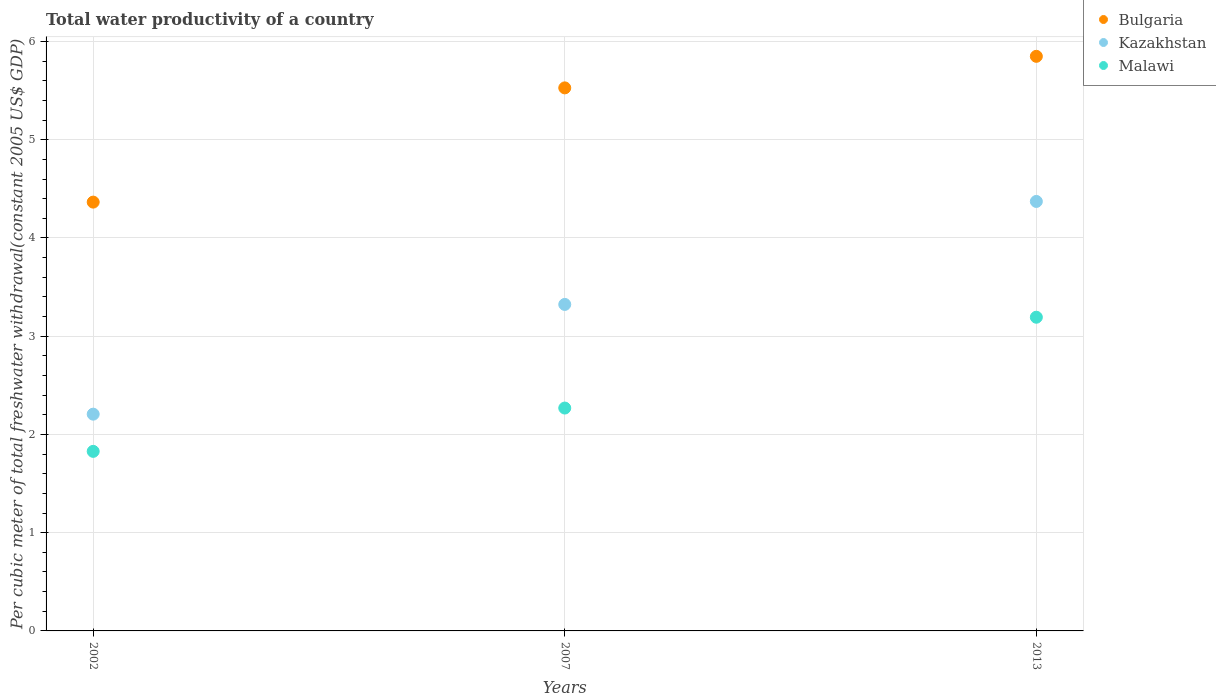What is the total water productivity in Bulgaria in 2013?
Keep it short and to the point. 5.85. Across all years, what is the maximum total water productivity in Malawi?
Ensure brevity in your answer.  3.19. Across all years, what is the minimum total water productivity in Kazakhstan?
Give a very brief answer. 2.21. In which year was the total water productivity in Malawi maximum?
Make the answer very short. 2013. In which year was the total water productivity in Bulgaria minimum?
Your answer should be compact. 2002. What is the total total water productivity in Kazakhstan in the graph?
Your answer should be very brief. 9.9. What is the difference between the total water productivity in Bulgaria in 2002 and that in 2007?
Offer a very short reply. -1.16. What is the difference between the total water productivity in Kazakhstan in 2013 and the total water productivity in Malawi in 2007?
Ensure brevity in your answer.  2.1. What is the average total water productivity in Bulgaria per year?
Your answer should be very brief. 5.25. In the year 2013, what is the difference between the total water productivity in Kazakhstan and total water productivity in Malawi?
Ensure brevity in your answer.  1.18. In how many years, is the total water productivity in Kazakhstan greater than 5.4 US$?
Offer a very short reply. 0. What is the ratio of the total water productivity in Kazakhstan in 2002 to that in 2007?
Make the answer very short. 0.66. What is the difference between the highest and the second highest total water productivity in Kazakhstan?
Your answer should be compact. 1.05. What is the difference between the highest and the lowest total water productivity in Bulgaria?
Provide a short and direct response. 1.48. Is the sum of the total water productivity in Kazakhstan in 2002 and 2013 greater than the maximum total water productivity in Bulgaria across all years?
Give a very brief answer. Yes. Does the total water productivity in Malawi monotonically increase over the years?
Provide a succinct answer. Yes. Is the total water productivity in Kazakhstan strictly greater than the total water productivity in Malawi over the years?
Offer a very short reply. Yes. Is the total water productivity in Kazakhstan strictly less than the total water productivity in Bulgaria over the years?
Give a very brief answer. Yes. How many years are there in the graph?
Provide a succinct answer. 3. Are the values on the major ticks of Y-axis written in scientific E-notation?
Provide a succinct answer. No. Does the graph contain grids?
Make the answer very short. Yes. How many legend labels are there?
Provide a succinct answer. 3. What is the title of the graph?
Your response must be concise. Total water productivity of a country. Does "Nigeria" appear as one of the legend labels in the graph?
Keep it short and to the point. No. What is the label or title of the X-axis?
Keep it short and to the point. Years. What is the label or title of the Y-axis?
Ensure brevity in your answer.  Per cubic meter of total freshwater withdrawal(constant 2005 US$ GDP). What is the Per cubic meter of total freshwater withdrawal(constant 2005 US$ GDP) in Bulgaria in 2002?
Ensure brevity in your answer.  4.37. What is the Per cubic meter of total freshwater withdrawal(constant 2005 US$ GDP) of Kazakhstan in 2002?
Offer a very short reply. 2.21. What is the Per cubic meter of total freshwater withdrawal(constant 2005 US$ GDP) in Malawi in 2002?
Provide a short and direct response. 1.83. What is the Per cubic meter of total freshwater withdrawal(constant 2005 US$ GDP) of Bulgaria in 2007?
Offer a terse response. 5.53. What is the Per cubic meter of total freshwater withdrawal(constant 2005 US$ GDP) of Kazakhstan in 2007?
Provide a short and direct response. 3.32. What is the Per cubic meter of total freshwater withdrawal(constant 2005 US$ GDP) of Malawi in 2007?
Make the answer very short. 2.27. What is the Per cubic meter of total freshwater withdrawal(constant 2005 US$ GDP) of Bulgaria in 2013?
Ensure brevity in your answer.  5.85. What is the Per cubic meter of total freshwater withdrawal(constant 2005 US$ GDP) of Kazakhstan in 2013?
Offer a terse response. 4.37. What is the Per cubic meter of total freshwater withdrawal(constant 2005 US$ GDP) in Malawi in 2013?
Provide a short and direct response. 3.19. Across all years, what is the maximum Per cubic meter of total freshwater withdrawal(constant 2005 US$ GDP) in Bulgaria?
Your answer should be compact. 5.85. Across all years, what is the maximum Per cubic meter of total freshwater withdrawal(constant 2005 US$ GDP) of Kazakhstan?
Your answer should be very brief. 4.37. Across all years, what is the maximum Per cubic meter of total freshwater withdrawal(constant 2005 US$ GDP) in Malawi?
Provide a succinct answer. 3.19. Across all years, what is the minimum Per cubic meter of total freshwater withdrawal(constant 2005 US$ GDP) in Bulgaria?
Ensure brevity in your answer.  4.37. Across all years, what is the minimum Per cubic meter of total freshwater withdrawal(constant 2005 US$ GDP) of Kazakhstan?
Your answer should be very brief. 2.21. Across all years, what is the minimum Per cubic meter of total freshwater withdrawal(constant 2005 US$ GDP) in Malawi?
Provide a succinct answer. 1.83. What is the total Per cubic meter of total freshwater withdrawal(constant 2005 US$ GDP) of Bulgaria in the graph?
Offer a terse response. 15.74. What is the total Per cubic meter of total freshwater withdrawal(constant 2005 US$ GDP) in Kazakhstan in the graph?
Make the answer very short. 9.9. What is the total Per cubic meter of total freshwater withdrawal(constant 2005 US$ GDP) in Malawi in the graph?
Your response must be concise. 7.29. What is the difference between the Per cubic meter of total freshwater withdrawal(constant 2005 US$ GDP) of Bulgaria in 2002 and that in 2007?
Make the answer very short. -1.16. What is the difference between the Per cubic meter of total freshwater withdrawal(constant 2005 US$ GDP) of Kazakhstan in 2002 and that in 2007?
Provide a succinct answer. -1.12. What is the difference between the Per cubic meter of total freshwater withdrawal(constant 2005 US$ GDP) in Malawi in 2002 and that in 2007?
Your answer should be very brief. -0.44. What is the difference between the Per cubic meter of total freshwater withdrawal(constant 2005 US$ GDP) of Bulgaria in 2002 and that in 2013?
Your answer should be very brief. -1.48. What is the difference between the Per cubic meter of total freshwater withdrawal(constant 2005 US$ GDP) of Kazakhstan in 2002 and that in 2013?
Offer a very short reply. -2.17. What is the difference between the Per cubic meter of total freshwater withdrawal(constant 2005 US$ GDP) of Malawi in 2002 and that in 2013?
Your answer should be very brief. -1.37. What is the difference between the Per cubic meter of total freshwater withdrawal(constant 2005 US$ GDP) in Bulgaria in 2007 and that in 2013?
Your answer should be compact. -0.32. What is the difference between the Per cubic meter of total freshwater withdrawal(constant 2005 US$ GDP) of Kazakhstan in 2007 and that in 2013?
Give a very brief answer. -1.05. What is the difference between the Per cubic meter of total freshwater withdrawal(constant 2005 US$ GDP) of Malawi in 2007 and that in 2013?
Your answer should be compact. -0.92. What is the difference between the Per cubic meter of total freshwater withdrawal(constant 2005 US$ GDP) in Bulgaria in 2002 and the Per cubic meter of total freshwater withdrawal(constant 2005 US$ GDP) in Kazakhstan in 2007?
Offer a terse response. 1.04. What is the difference between the Per cubic meter of total freshwater withdrawal(constant 2005 US$ GDP) of Bulgaria in 2002 and the Per cubic meter of total freshwater withdrawal(constant 2005 US$ GDP) of Malawi in 2007?
Offer a very short reply. 2.1. What is the difference between the Per cubic meter of total freshwater withdrawal(constant 2005 US$ GDP) in Kazakhstan in 2002 and the Per cubic meter of total freshwater withdrawal(constant 2005 US$ GDP) in Malawi in 2007?
Your answer should be very brief. -0.06. What is the difference between the Per cubic meter of total freshwater withdrawal(constant 2005 US$ GDP) in Bulgaria in 2002 and the Per cubic meter of total freshwater withdrawal(constant 2005 US$ GDP) in Kazakhstan in 2013?
Your answer should be compact. -0.01. What is the difference between the Per cubic meter of total freshwater withdrawal(constant 2005 US$ GDP) of Bulgaria in 2002 and the Per cubic meter of total freshwater withdrawal(constant 2005 US$ GDP) of Malawi in 2013?
Offer a very short reply. 1.17. What is the difference between the Per cubic meter of total freshwater withdrawal(constant 2005 US$ GDP) in Kazakhstan in 2002 and the Per cubic meter of total freshwater withdrawal(constant 2005 US$ GDP) in Malawi in 2013?
Your answer should be very brief. -0.99. What is the difference between the Per cubic meter of total freshwater withdrawal(constant 2005 US$ GDP) of Bulgaria in 2007 and the Per cubic meter of total freshwater withdrawal(constant 2005 US$ GDP) of Kazakhstan in 2013?
Keep it short and to the point. 1.16. What is the difference between the Per cubic meter of total freshwater withdrawal(constant 2005 US$ GDP) of Bulgaria in 2007 and the Per cubic meter of total freshwater withdrawal(constant 2005 US$ GDP) of Malawi in 2013?
Your response must be concise. 2.33. What is the difference between the Per cubic meter of total freshwater withdrawal(constant 2005 US$ GDP) of Kazakhstan in 2007 and the Per cubic meter of total freshwater withdrawal(constant 2005 US$ GDP) of Malawi in 2013?
Your response must be concise. 0.13. What is the average Per cubic meter of total freshwater withdrawal(constant 2005 US$ GDP) of Bulgaria per year?
Your response must be concise. 5.25. What is the average Per cubic meter of total freshwater withdrawal(constant 2005 US$ GDP) in Kazakhstan per year?
Your answer should be very brief. 3.3. What is the average Per cubic meter of total freshwater withdrawal(constant 2005 US$ GDP) of Malawi per year?
Provide a short and direct response. 2.43. In the year 2002, what is the difference between the Per cubic meter of total freshwater withdrawal(constant 2005 US$ GDP) in Bulgaria and Per cubic meter of total freshwater withdrawal(constant 2005 US$ GDP) in Kazakhstan?
Keep it short and to the point. 2.16. In the year 2002, what is the difference between the Per cubic meter of total freshwater withdrawal(constant 2005 US$ GDP) of Bulgaria and Per cubic meter of total freshwater withdrawal(constant 2005 US$ GDP) of Malawi?
Offer a terse response. 2.54. In the year 2002, what is the difference between the Per cubic meter of total freshwater withdrawal(constant 2005 US$ GDP) in Kazakhstan and Per cubic meter of total freshwater withdrawal(constant 2005 US$ GDP) in Malawi?
Your answer should be compact. 0.38. In the year 2007, what is the difference between the Per cubic meter of total freshwater withdrawal(constant 2005 US$ GDP) of Bulgaria and Per cubic meter of total freshwater withdrawal(constant 2005 US$ GDP) of Kazakhstan?
Offer a very short reply. 2.2. In the year 2007, what is the difference between the Per cubic meter of total freshwater withdrawal(constant 2005 US$ GDP) of Bulgaria and Per cubic meter of total freshwater withdrawal(constant 2005 US$ GDP) of Malawi?
Give a very brief answer. 3.26. In the year 2007, what is the difference between the Per cubic meter of total freshwater withdrawal(constant 2005 US$ GDP) of Kazakhstan and Per cubic meter of total freshwater withdrawal(constant 2005 US$ GDP) of Malawi?
Offer a terse response. 1.05. In the year 2013, what is the difference between the Per cubic meter of total freshwater withdrawal(constant 2005 US$ GDP) of Bulgaria and Per cubic meter of total freshwater withdrawal(constant 2005 US$ GDP) of Kazakhstan?
Your answer should be compact. 1.48. In the year 2013, what is the difference between the Per cubic meter of total freshwater withdrawal(constant 2005 US$ GDP) of Bulgaria and Per cubic meter of total freshwater withdrawal(constant 2005 US$ GDP) of Malawi?
Your response must be concise. 2.66. In the year 2013, what is the difference between the Per cubic meter of total freshwater withdrawal(constant 2005 US$ GDP) of Kazakhstan and Per cubic meter of total freshwater withdrawal(constant 2005 US$ GDP) of Malawi?
Make the answer very short. 1.18. What is the ratio of the Per cubic meter of total freshwater withdrawal(constant 2005 US$ GDP) of Bulgaria in 2002 to that in 2007?
Offer a terse response. 0.79. What is the ratio of the Per cubic meter of total freshwater withdrawal(constant 2005 US$ GDP) of Kazakhstan in 2002 to that in 2007?
Keep it short and to the point. 0.66. What is the ratio of the Per cubic meter of total freshwater withdrawal(constant 2005 US$ GDP) in Malawi in 2002 to that in 2007?
Offer a very short reply. 0.81. What is the ratio of the Per cubic meter of total freshwater withdrawal(constant 2005 US$ GDP) of Bulgaria in 2002 to that in 2013?
Make the answer very short. 0.75. What is the ratio of the Per cubic meter of total freshwater withdrawal(constant 2005 US$ GDP) in Kazakhstan in 2002 to that in 2013?
Your answer should be very brief. 0.5. What is the ratio of the Per cubic meter of total freshwater withdrawal(constant 2005 US$ GDP) of Malawi in 2002 to that in 2013?
Provide a succinct answer. 0.57. What is the ratio of the Per cubic meter of total freshwater withdrawal(constant 2005 US$ GDP) of Bulgaria in 2007 to that in 2013?
Ensure brevity in your answer.  0.95. What is the ratio of the Per cubic meter of total freshwater withdrawal(constant 2005 US$ GDP) of Kazakhstan in 2007 to that in 2013?
Make the answer very short. 0.76. What is the ratio of the Per cubic meter of total freshwater withdrawal(constant 2005 US$ GDP) of Malawi in 2007 to that in 2013?
Your answer should be very brief. 0.71. What is the difference between the highest and the second highest Per cubic meter of total freshwater withdrawal(constant 2005 US$ GDP) of Bulgaria?
Your response must be concise. 0.32. What is the difference between the highest and the second highest Per cubic meter of total freshwater withdrawal(constant 2005 US$ GDP) in Kazakhstan?
Offer a very short reply. 1.05. What is the difference between the highest and the second highest Per cubic meter of total freshwater withdrawal(constant 2005 US$ GDP) of Malawi?
Provide a succinct answer. 0.92. What is the difference between the highest and the lowest Per cubic meter of total freshwater withdrawal(constant 2005 US$ GDP) of Bulgaria?
Ensure brevity in your answer.  1.48. What is the difference between the highest and the lowest Per cubic meter of total freshwater withdrawal(constant 2005 US$ GDP) of Kazakhstan?
Keep it short and to the point. 2.17. What is the difference between the highest and the lowest Per cubic meter of total freshwater withdrawal(constant 2005 US$ GDP) in Malawi?
Keep it short and to the point. 1.37. 